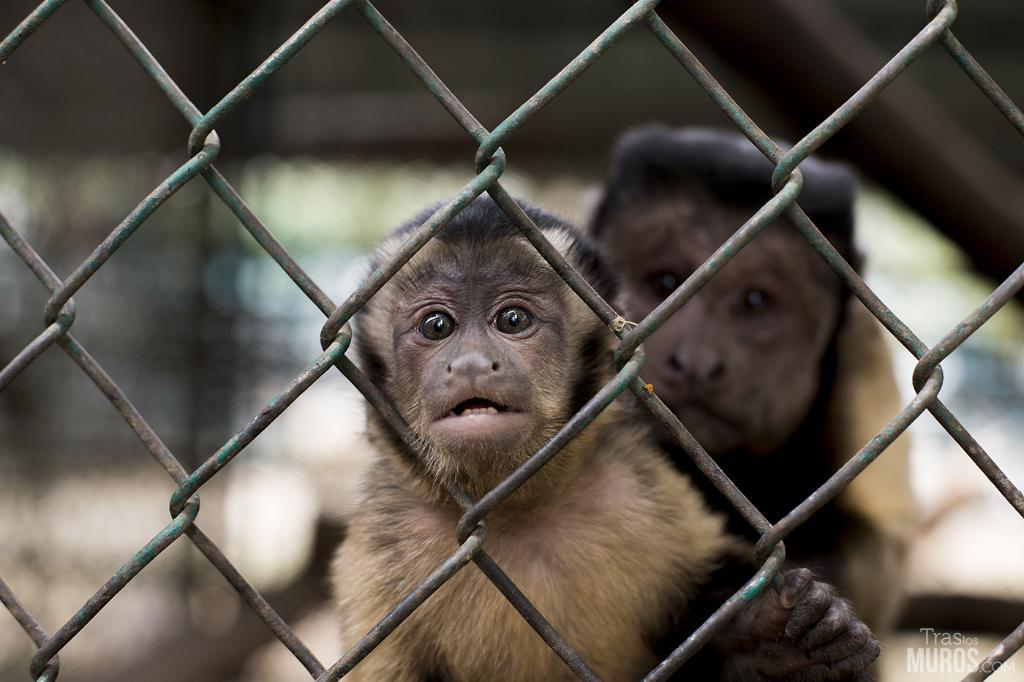How many monkeys are present in the image? There are two monkeys in the image. What can be seen in the background of the image? The background of the image is blurry. Is there any structure or barrier visible in the image? Yes, there appears to be a fence in the image. Can you describe any additional features or elements in the image? There is a watermark in the image. What type of ball is being used by the monkeys in the image? There is no ball present in the image; it features two monkeys and a fence. Are the monkeys engaged in a fight in the image? There is no indication of a fight between the monkeys in the image. 